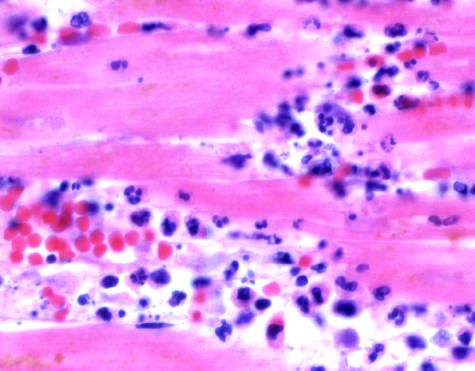what do the photomicrographs show in the myocardium after ischemic necrosis infarction?
Answer the question using a single word or phrase. An inflammatory reaction 